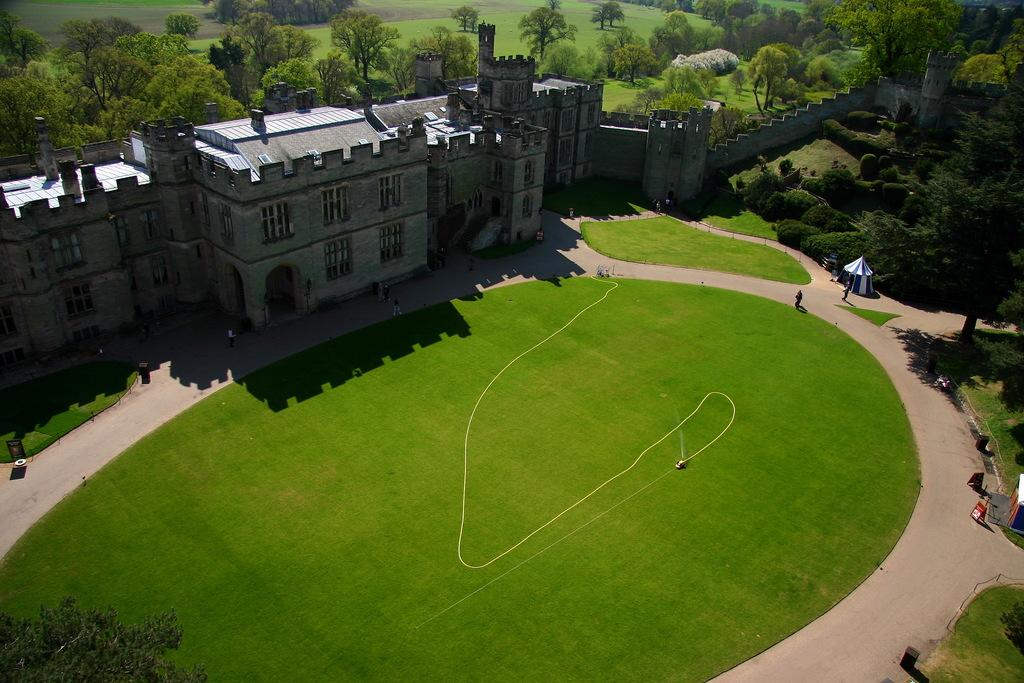What type of view is depicted in the image? The image is an aerial view. What structures can be seen in the image? There are buildings in the image, and their roofs are visible. What architectural features are present in the image? There are windows and walls visible in the image. What natural elements can be seen in the image? Trees and grass are visible in the image. What additional man-made structures can be seen in the image? There is a tent and a vehicle present in the image. What other objects are visible in the image? Boards and roads are visible in the image. What is the ground like in the image? The ground is visible in the image. Are there any people in the image? Yes, there are persons in the image. Where is the market located in the image? There is no market present in the image. What type of linen is draped over the trees in the image? There is no linen draped over the trees in the image. 